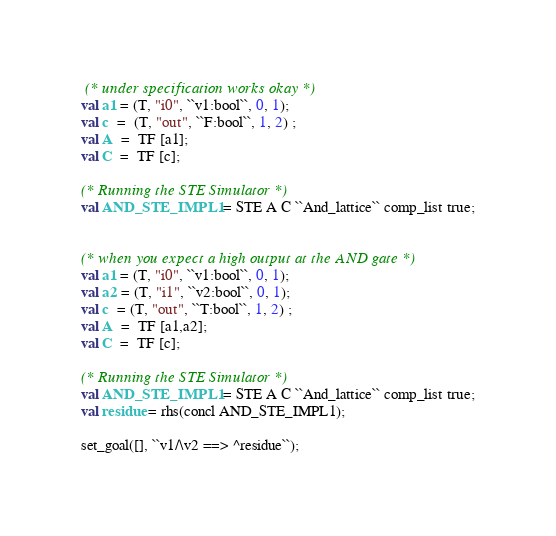<code> <loc_0><loc_0><loc_500><loc_500><_SML_> (* under specification works okay *)
val a1 = (T, "i0", ``v1:bool``, 0, 1);
val c  =  (T, "out", ``F:bool``, 1, 2) ;
val A  =  TF [a1];
val C  =  TF [c];

(* Running the STE Simulator *)
val AND_STE_IMPL1 = STE A C ``And_lattice`` comp_list true;


(* when you expect a high output at the AND gate *)
val a1 = (T, "i0", ``v1:bool``, 0, 1);
val a2 = (T, "i1", ``v2:bool``, 0, 1);
val c  = (T, "out", ``T:bool``, 1, 2) ;
val A  =  TF [a1,a2];
val C  =  TF [c];

(* Running the STE Simulator *)
val AND_STE_IMPL1 = STE A C ``And_lattice`` comp_list true;
val residue = rhs(concl AND_STE_IMPL1);

set_goal([], ``v1/\v2 ==> ^residue``);

</code> 